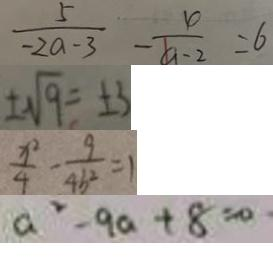Convert formula to latex. <formula><loc_0><loc_0><loc_500><loc_500>\frac { 5 } { - 2 a - 3 } - \frac { 4 } { a - 2 } = 6 
 \pm \sqrt { 9 } = \pm 3 
 \frac { x ^ { 2 } } { 4 } - \frac { 9 } { 4 b ^ { 2 } } = 1 
 a ^ { 2 } - 9 a + 8 = 0</formula> 